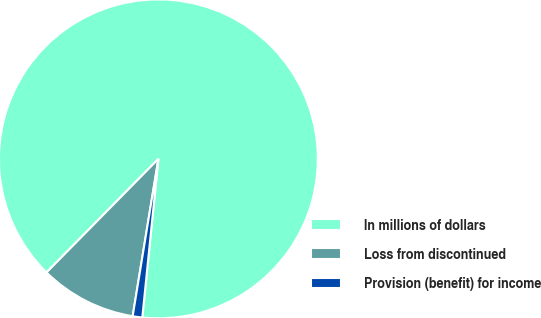Convert chart to OTSL. <chart><loc_0><loc_0><loc_500><loc_500><pie_chart><fcel>In millions of dollars<fcel>Loss from discontinued<fcel>Provision (benefit) for income<nl><fcel>89.23%<fcel>9.8%<fcel>0.97%<nl></chart> 